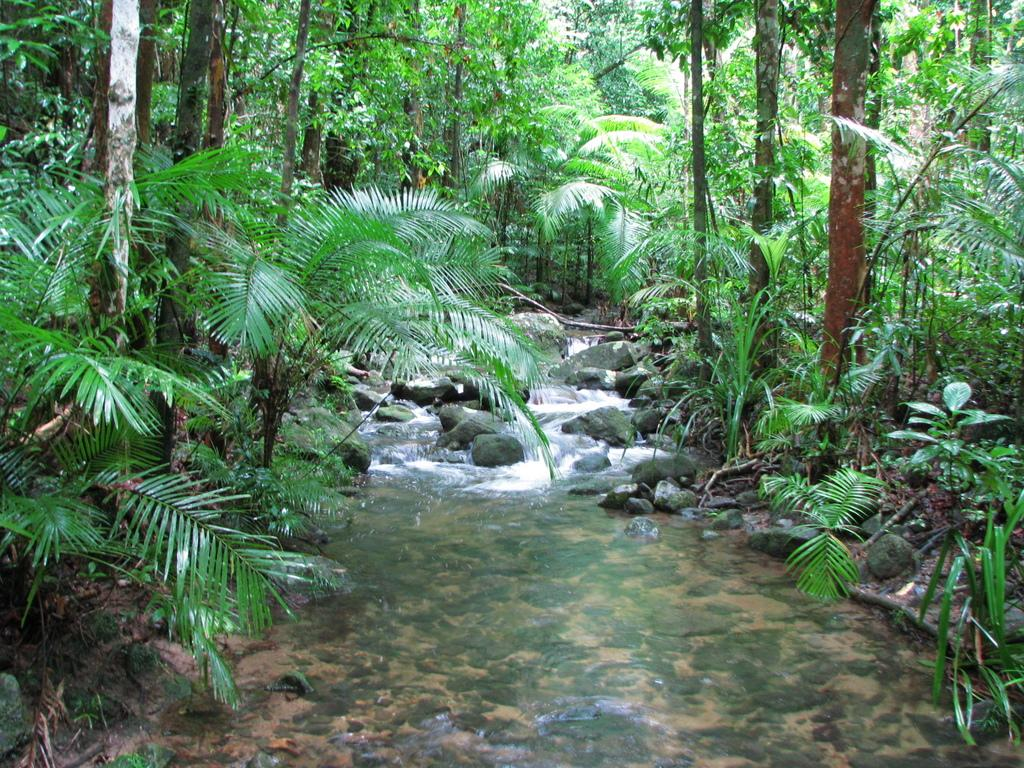What is the main subject in the center of the image? There is water in the center of the image. What can be seen in the background of the image? There are rocks and trees in the background of the image. How many pizzas are being served to the visitors in the image? There are no pizzas or visitors present in the image; it features water, rocks, and trees. 